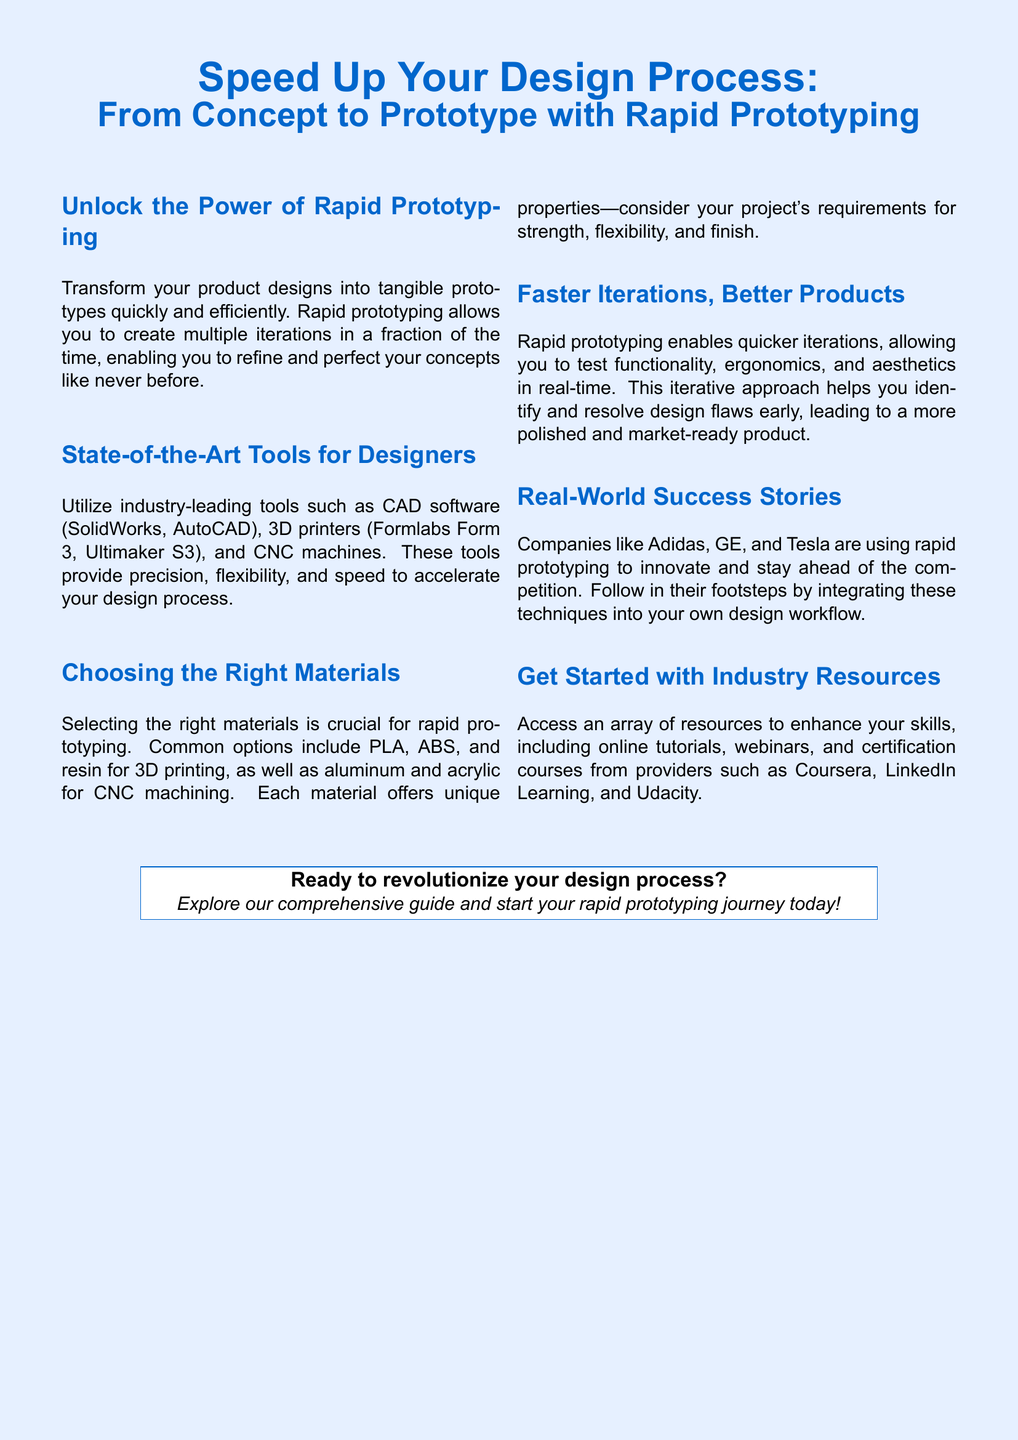What is the main focus of the advertisement? The main focus is on using rapid prototyping to speed up the design process.
Answer: Speed up design process Which companies are mentioned as using rapid prototyping? Adidas, GE, and Tesla are mentioned as examples of companies using these techniques.
Answer: Adidas, GE, Tesla What are two CAD software examples provided? The advertisement lists SolidWorks and AutoCAD as examples of CAD software.
Answer: SolidWorks, AutoCAD What is one common material used for 3D printing? PLA is mentioned as a common material for 3D printing.
Answer: PLA What is the benefit of faster iterations mentioned in the document? The benefit of faster iterations is identifying and resolving design flaws early.
Answer: Identify design flaws early What types of resources can enhance skills in rapid prototyping? Online tutorials, webinars, and certification courses can enhance skills.
Answer: Online tutorials, webinars, certification courses What is a state-of-the-art tool for designers listed in the document? 3D printers are mentioned as state-of-the-art tools for designers.
Answer: 3D printers What is the tone of the advertisement towards rapid prototyping? The tone is encouraging and promotional about adopting rapid prototyping.
Answer: Encouraging What is the primary action encouraged at the end of the advertisement? The advertisement encourages readers to explore a comprehensive guide.
Answer: Explore guide 